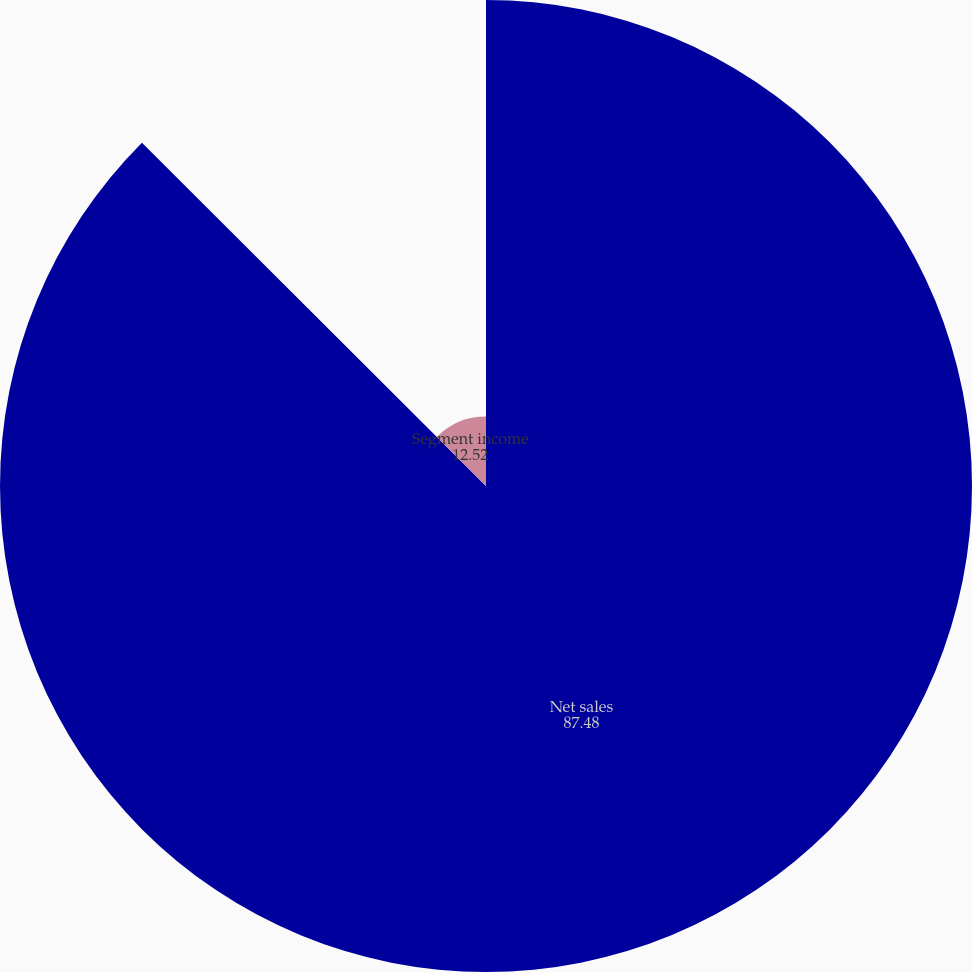Convert chart to OTSL. <chart><loc_0><loc_0><loc_500><loc_500><pie_chart><fcel>Net sales<fcel>Segment income<nl><fcel>87.48%<fcel>12.52%<nl></chart> 